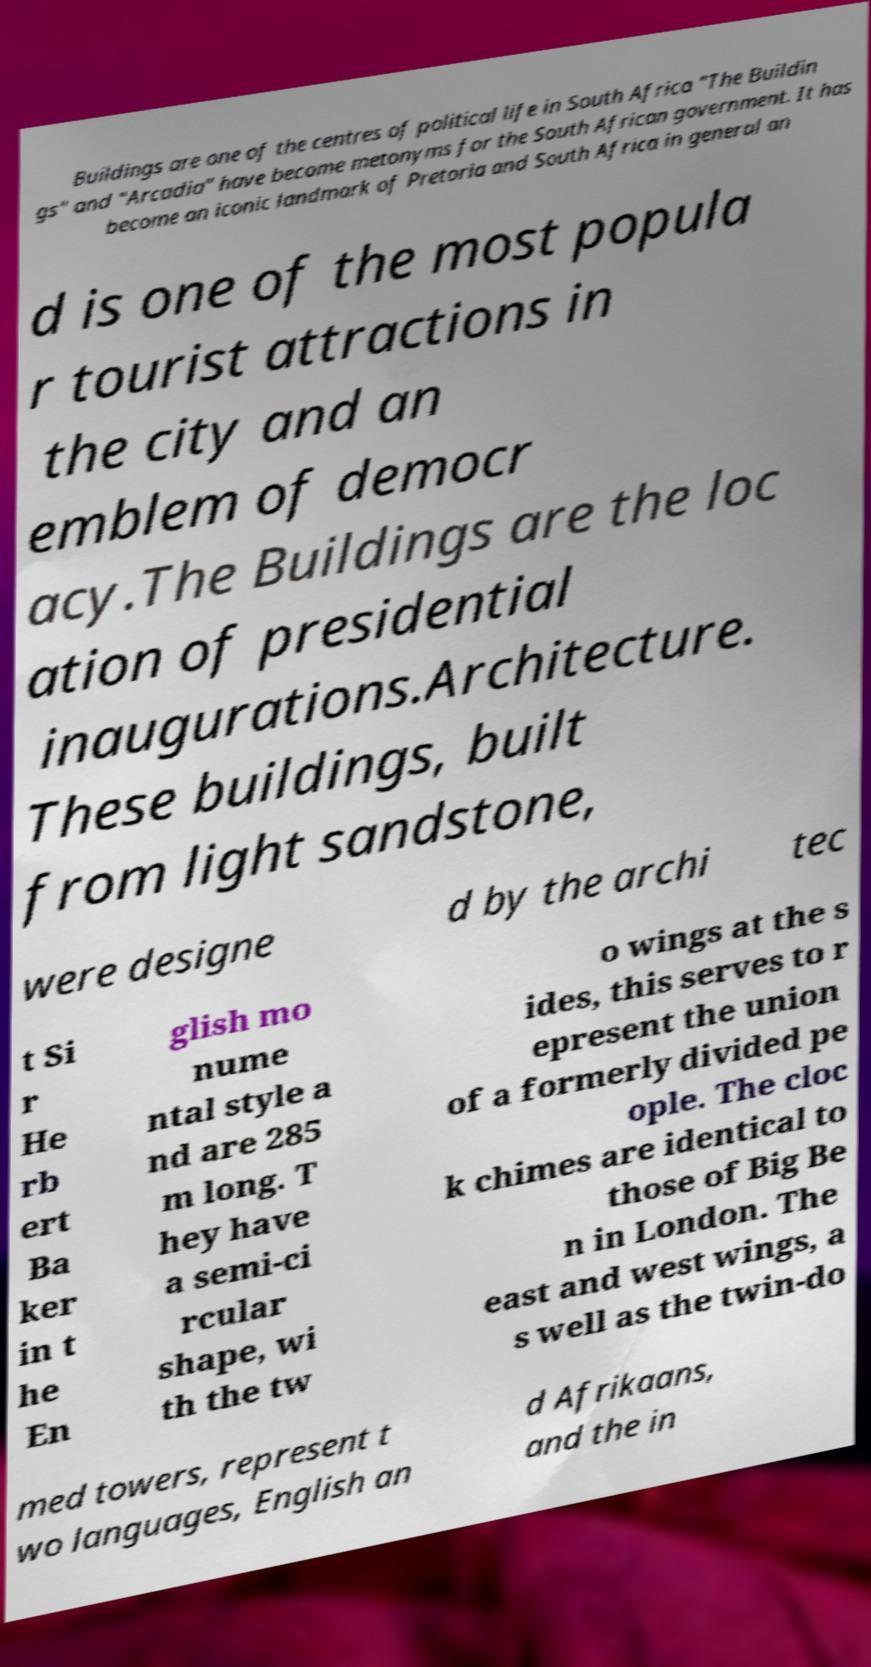What messages or text are displayed in this image? I need them in a readable, typed format. Buildings are one of the centres of political life in South Africa "The Buildin gs" and "Arcadia" have become metonyms for the South African government. It has become an iconic landmark of Pretoria and South Africa in general an d is one of the most popula r tourist attractions in the city and an emblem of democr acy.The Buildings are the loc ation of presidential inaugurations.Architecture. These buildings, built from light sandstone, were designe d by the archi tec t Si r He rb ert Ba ker in t he En glish mo nume ntal style a nd are 285 m long. T hey have a semi-ci rcular shape, wi th the tw o wings at the s ides, this serves to r epresent the union of a formerly divided pe ople. The cloc k chimes are identical to those of Big Be n in London. The east and west wings, a s well as the twin-do med towers, represent t wo languages, English an d Afrikaans, and the in 